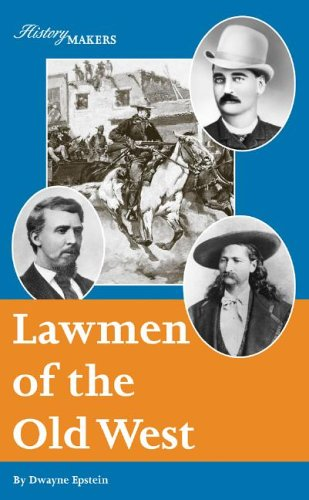Is this a sci-fi book? No, this book does not delve into science fiction but rather explores historical themes, chronicling the lives of law enforcement figures in the Old West. 